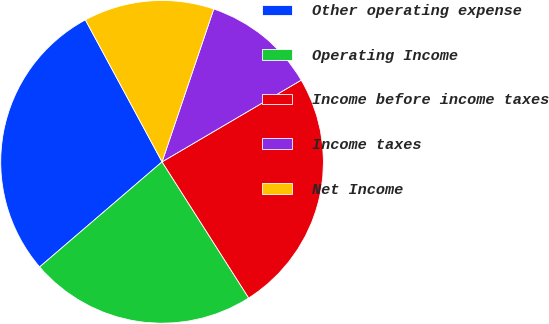Convert chart. <chart><loc_0><loc_0><loc_500><loc_500><pie_chart><fcel>Other operating expense<fcel>Operating Income<fcel>Income before income taxes<fcel>Income taxes<fcel>Net Income<nl><fcel>28.41%<fcel>22.73%<fcel>24.43%<fcel>11.36%<fcel>13.07%<nl></chart> 